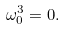<formula> <loc_0><loc_0><loc_500><loc_500>\omega _ { 0 } ^ { 3 } = 0 .</formula> 